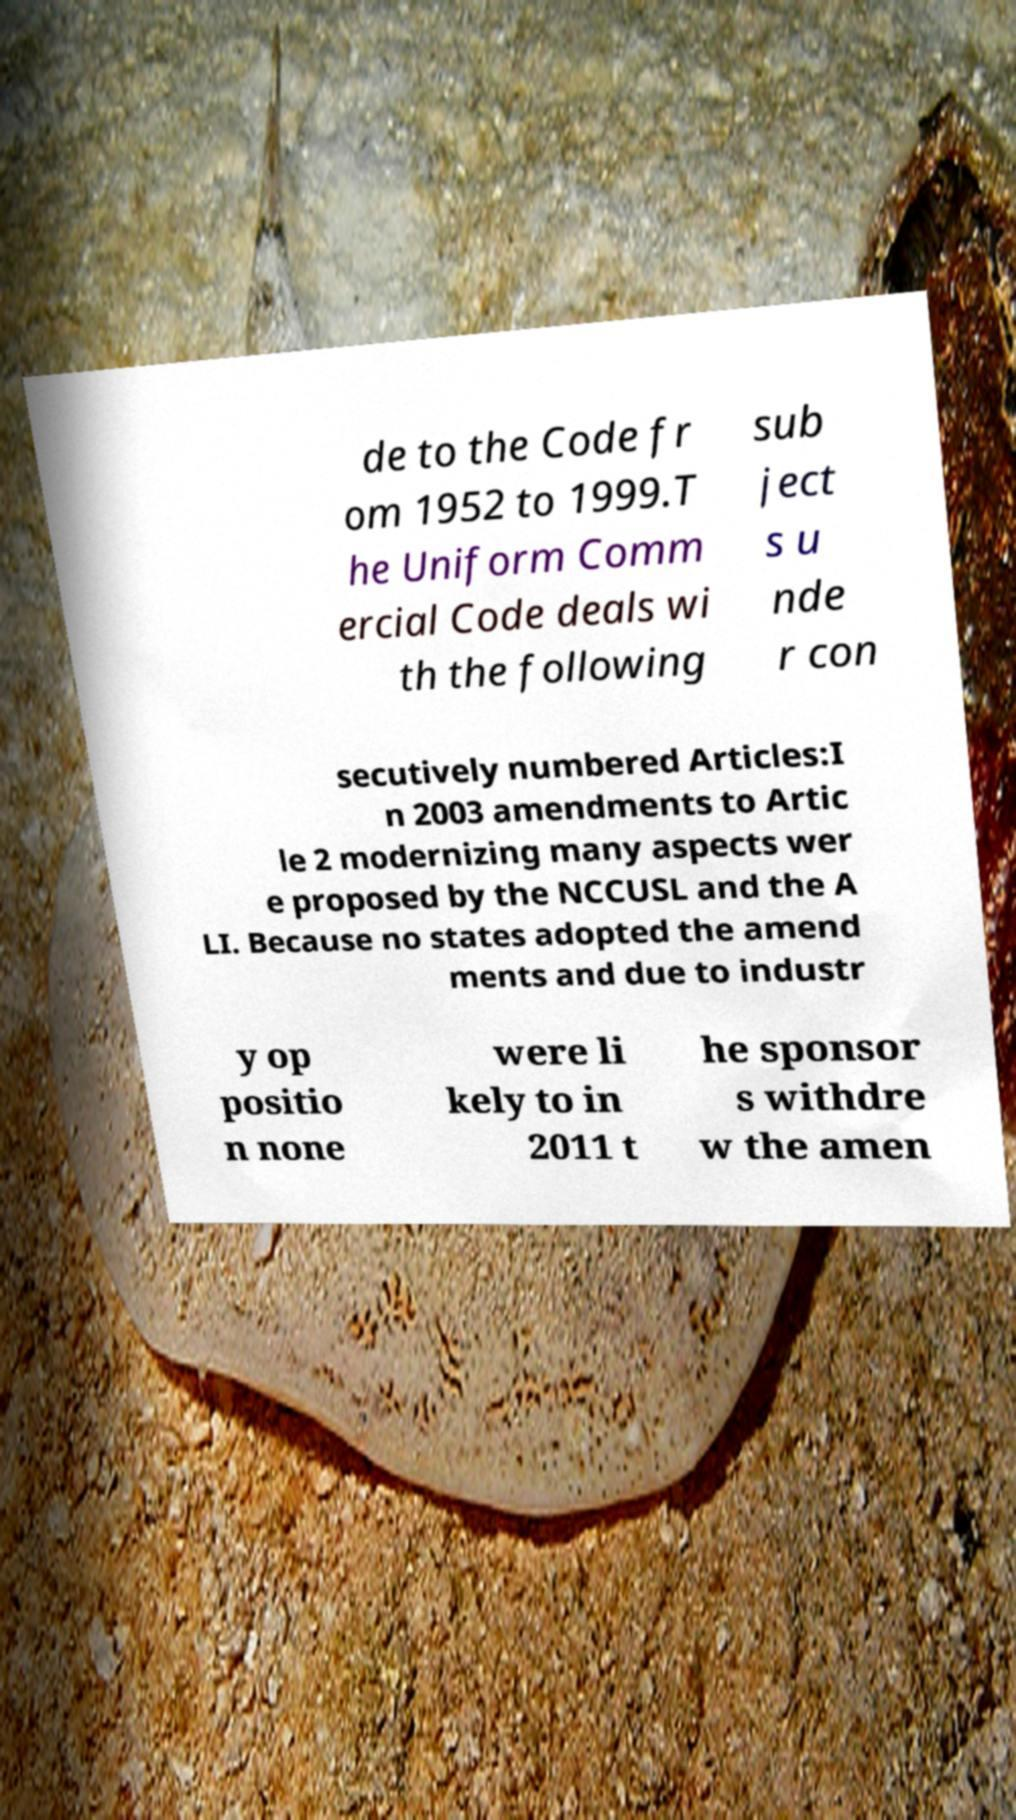Please identify and transcribe the text found in this image. de to the Code fr om 1952 to 1999.T he Uniform Comm ercial Code deals wi th the following sub ject s u nde r con secutively numbered Articles:I n 2003 amendments to Artic le 2 modernizing many aspects wer e proposed by the NCCUSL and the A LI. Because no states adopted the amend ments and due to industr y op positio n none were li kely to in 2011 t he sponsor s withdre w the amen 